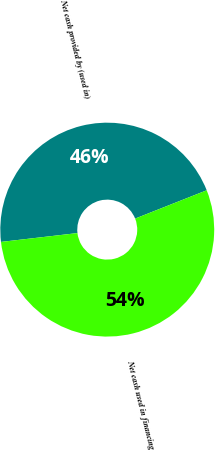<chart> <loc_0><loc_0><loc_500><loc_500><pie_chart><fcel>Net cash provided by (used in)<fcel>Net cash used in financing<nl><fcel>45.84%<fcel>54.16%<nl></chart> 